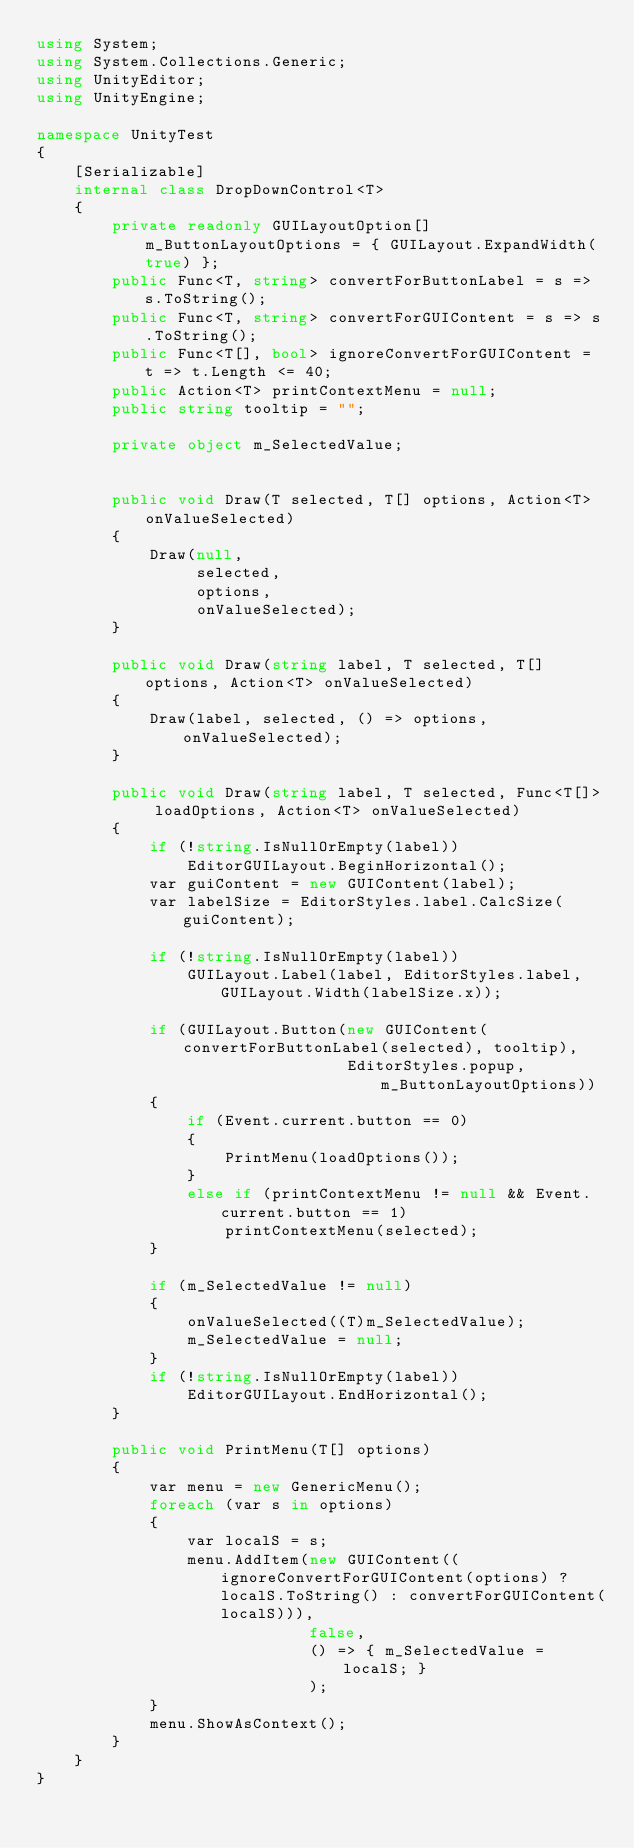Convert code to text. <code><loc_0><loc_0><loc_500><loc_500><_C#_>using System;
using System.Collections.Generic;
using UnityEditor;
using UnityEngine;

namespace UnityTest
{
    [Serializable]
    internal class DropDownControl<T>
    {
        private readonly GUILayoutOption[] m_ButtonLayoutOptions = { GUILayout.ExpandWidth(true) };
        public Func<T, string> convertForButtonLabel = s => s.ToString();
        public Func<T, string> convertForGUIContent = s => s.ToString();
        public Func<T[], bool> ignoreConvertForGUIContent = t => t.Length <= 40;
        public Action<T> printContextMenu = null;
        public string tooltip = "";

        private object m_SelectedValue;


        public void Draw(T selected, T[] options, Action<T> onValueSelected)
        {
            Draw(null,
                 selected,
                 options,
                 onValueSelected);
        }

        public void Draw(string label, T selected, T[] options, Action<T> onValueSelected)
        {
            Draw(label, selected, () => options, onValueSelected);
        }

        public void Draw(string label, T selected, Func<T[]> loadOptions, Action<T> onValueSelected)
        {
            if (!string.IsNullOrEmpty(label))
                EditorGUILayout.BeginHorizontal();
            var guiContent = new GUIContent(label);
            var labelSize = EditorStyles.label.CalcSize(guiContent);

            if (!string.IsNullOrEmpty(label))
                GUILayout.Label(label, EditorStyles.label, GUILayout.Width(labelSize.x));

            if (GUILayout.Button(new GUIContent(convertForButtonLabel(selected), tooltip),
                                 EditorStyles.popup, m_ButtonLayoutOptions))
            {
                if (Event.current.button == 0)
                {
                    PrintMenu(loadOptions());
                }
                else if (printContextMenu != null && Event.current.button == 1)
                    printContextMenu(selected);
            }

            if (m_SelectedValue != null)
            {
                onValueSelected((T)m_SelectedValue);
                m_SelectedValue = null;
            }
            if (!string.IsNullOrEmpty(label))
                EditorGUILayout.EndHorizontal();
        }

        public void PrintMenu(T[] options)
        {
            var menu = new GenericMenu();
            foreach (var s in options)
            {
                var localS = s;
                menu.AddItem(new GUIContent((ignoreConvertForGUIContent(options) ? localS.ToString() : convertForGUIContent(localS))),
                             false,
                             () => { m_SelectedValue = localS; }
                             );
            }
            menu.ShowAsContext();
        }
    }
}
</code> 